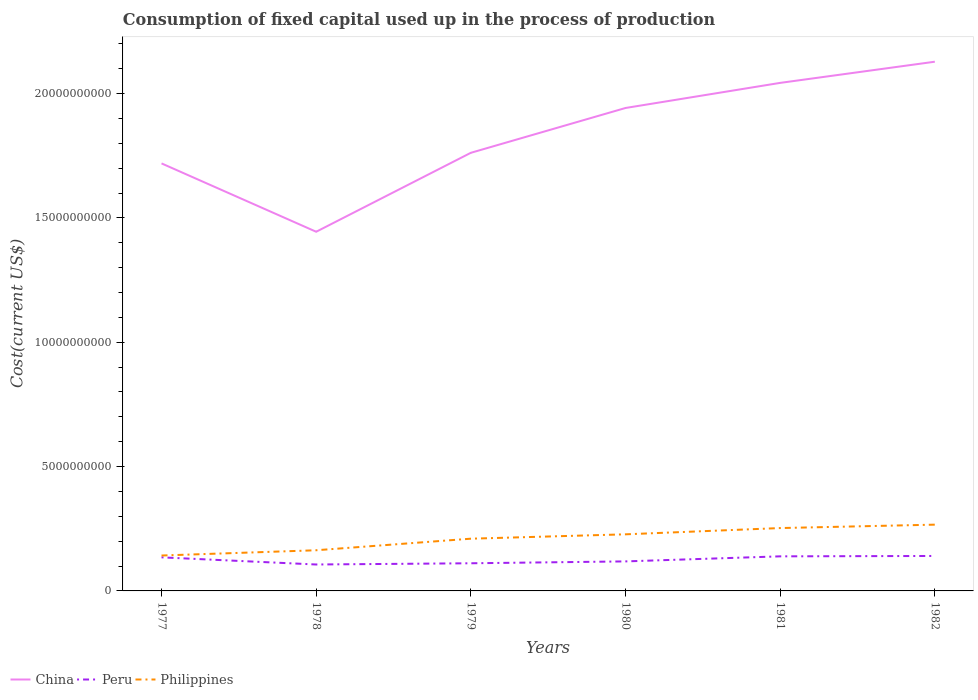How many different coloured lines are there?
Provide a short and direct response. 3. Is the number of lines equal to the number of legend labels?
Keep it short and to the point. Yes. Across all years, what is the maximum amount consumed in the process of production in Peru?
Your response must be concise. 1.06e+09. In which year was the amount consumed in the process of production in Peru maximum?
Offer a terse response. 1978. What is the total amount consumed in the process of production in Philippines in the graph?
Your answer should be very brief. -1.24e+09. What is the difference between the highest and the second highest amount consumed in the process of production in China?
Ensure brevity in your answer.  6.84e+09. Is the amount consumed in the process of production in China strictly greater than the amount consumed in the process of production in Philippines over the years?
Your response must be concise. No. How many lines are there?
Offer a very short reply. 3. How many years are there in the graph?
Offer a very short reply. 6. Does the graph contain any zero values?
Provide a succinct answer. No. How are the legend labels stacked?
Make the answer very short. Horizontal. What is the title of the graph?
Give a very brief answer. Consumption of fixed capital used up in the process of production. Does "Zimbabwe" appear as one of the legend labels in the graph?
Your answer should be very brief. No. What is the label or title of the X-axis?
Make the answer very short. Years. What is the label or title of the Y-axis?
Offer a very short reply. Cost(current US$). What is the Cost(current US$) of China in 1977?
Offer a terse response. 1.72e+1. What is the Cost(current US$) in Peru in 1977?
Make the answer very short. 1.35e+09. What is the Cost(current US$) in Philippines in 1977?
Your answer should be compact. 1.42e+09. What is the Cost(current US$) in China in 1978?
Ensure brevity in your answer.  1.44e+1. What is the Cost(current US$) in Peru in 1978?
Give a very brief answer. 1.06e+09. What is the Cost(current US$) of Philippines in 1978?
Offer a very short reply. 1.64e+09. What is the Cost(current US$) in China in 1979?
Your response must be concise. 1.76e+1. What is the Cost(current US$) in Peru in 1979?
Your response must be concise. 1.11e+09. What is the Cost(current US$) of Philippines in 1979?
Give a very brief answer. 2.10e+09. What is the Cost(current US$) of China in 1980?
Your answer should be compact. 1.94e+1. What is the Cost(current US$) of Peru in 1980?
Provide a succinct answer. 1.19e+09. What is the Cost(current US$) in Philippines in 1980?
Offer a very short reply. 2.28e+09. What is the Cost(current US$) in China in 1981?
Your answer should be very brief. 2.04e+1. What is the Cost(current US$) in Peru in 1981?
Offer a very short reply. 1.39e+09. What is the Cost(current US$) in Philippines in 1981?
Keep it short and to the point. 2.53e+09. What is the Cost(current US$) in China in 1982?
Give a very brief answer. 2.13e+1. What is the Cost(current US$) in Peru in 1982?
Give a very brief answer. 1.41e+09. What is the Cost(current US$) of Philippines in 1982?
Provide a short and direct response. 2.66e+09. Across all years, what is the maximum Cost(current US$) in China?
Your answer should be compact. 2.13e+1. Across all years, what is the maximum Cost(current US$) of Peru?
Offer a terse response. 1.41e+09. Across all years, what is the maximum Cost(current US$) of Philippines?
Give a very brief answer. 2.66e+09. Across all years, what is the minimum Cost(current US$) in China?
Make the answer very short. 1.44e+1. Across all years, what is the minimum Cost(current US$) in Peru?
Provide a short and direct response. 1.06e+09. Across all years, what is the minimum Cost(current US$) in Philippines?
Give a very brief answer. 1.42e+09. What is the total Cost(current US$) of China in the graph?
Keep it short and to the point. 1.10e+11. What is the total Cost(current US$) of Peru in the graph?
Offer a terse response. 7.51e+09. What is the total Cost(current US$) in Philippines in the graph?
Make the answer very short. 1.26e+1. What is the difference between the Cost(current US$) in China in 1977 and that in 1978?
Offer a terse response. 2.75e+09. What is the difference between the Cost(current US$) of Peru in 1977 and that in 1978?
Give a very brief answer. 2.88e+08. What is the difference between the Cost(current US$) in Philippines in 1977 and that in 1978?
Offer a very short reply. -2.12e+08. What is the difference between the Cost(current US$) in China in 1977 and that in 1979?
Your answer should be compact. -4.26e+08. What is the difference between the Cost(current US$) of Peru in 1977 and that in 1979?
Provide a succinct answer. 2.38e+08. What is the difference between the Cost(current US$) of Philippines in 1977 and that in 1979?
Offer a terse response. -6.77e+08. What is the difference between the Cost(current US$) in China in 1977 and that in 1980?
Give a very brief answer. -2.23e+09. What is the difference between the Cost(current US$) in Peru in 1977 and that in 1980?
Give a very brief answer. 1.63e+08. What is the difference between the Cost(current US$) in Philippines in 1977 and that in 1980?
Offer a very short reply. -8.52e+08. What is the difference between the Cost(current US$) of China in 1977 and that in 1981?
Keep it short and to the point. -3.24e+09. What is the difference between the Cost(current US$) in Peru in 1977 and that in 1981?
Make the answer very short. -4.03e+07. What is the difference between the Cost(current US$) in Philippines in 1977 and that in 1981?
Your answer should be very brief. -1.10e+09. What is the difference between the Cost(current US$) in China in 1977 and that in 1982?
Your answer should be very brief. -4.09e+09. What is the difference between the Cost(current US$) of Peru in 1977 and that in 1982?
Offer a very short reply. -5.58e+07. What is the difference between the Cost(current US$) in Philippines in 1977 and that in 1982?
Give a very brief answer. -1.24e+09. What is the difference between the Cost(current US$) in China in 1978 and that in 1979?
Provide a succinct answer. -3.17e+09. What is the difference between the Cost(current US$) of Peru in 1978 and that in 1979?
Make the answer very short. -4.93e+07. What is the difference between the Cost(current US$) in Philippines in 1978 and that in 1979?
Make the answer very short. -4.65e+08. What is the difference between the Cost(current US$) in China in 1978 and that in 1980?
Offer a very short reply. -4.98e+09. What is the difference between the Cost(current US$) in Peru in 1978 and that in 1980?
Make the answer very short. -1.25e+08. What is the difference between the Cost(current US$) in Philippines in 1978 and that in 1980?
Offer a very short reply. -6.41e+08. What is the difference between the Cost(current US$) in China in 1978 and that in 1981?
Provide a succinct answer. -5.99e+09. What is the difference between the Cost(current US$) of Peru in 1978 and that in 1981?
Your answer should be compact. -3.28e+08. What is the difference between the Cost(current US$) in Philippines in 1978 and that in 1981?
Keep it short and to the point. -8.92e+08. What is the difference between the Cost(current US$) in China in 1978 and that in 1982?
Give a very brief answer. -6.84e+09. What is the difference between the Cost(current US$) in Peru in 1978 and that in 1982?
Make the answer very short. -3.43e+08. What is the difference between the Cost(current US$) of Philippines in 1978 and that in 1982?
Your response must be concise. -1.03e+09. What is the difference between the Cost(current US$) in China in 1979 and that in 1980?
Make the answer very short. -1.80e+09. What is the difference between the Cost(current US$) of Peru in 1979 and that in 1980?
Provide a short and direct response. -7.55e+07. What is the difference between the Cost(current US$) in Philippines in 1979 and that in 1980?
Offer a very short reply. -1.76e+08. What is the difference between the Cost(current US$) in China in 1979 and that in 1981?
Give a very brief answer. -2.81e+09. What is the difference between the Cost(current US$) in Peru in 1979 and that in 1981?
Keep it short and to the point. -2.78e+08. What is the difference between the Cost(current US$) in Philippines in 1979 and that in 1981?
Provide a short and direct response. -4.27e+08. What is the difference between the Cost(current US$) of China in 1979 and that in 1982?
Your response must be concise. -3.66e+09. What is the difference between the Cost(current US$) of Peru in 1979 and that in 1982?
Make the answer very short. -2.94e+08. What is the difference between the Cost(current US$) of Philippines in 1979 and that in 1982?
Your response must be concise. -5.64e+08. What is the difference between the Cost(current US$) in China in 1980 and that in 1981?
Keep it short and to the point. -1.01e+09. What is the difference between the Cost(current US$) in Peru in 1980 and that in 1981?
Make the answer very short. -2.03e+08. What is the difference between the Cost(current US$) of Philippines in 1980 and that in 1981?
Offer a very short reply. -2.52e+08. What is the difference between the Cost(current US$) in China in 1980 and that in 1982?
Your answer should be compact. -1.86e+09. What is the difference between the Cost(current US$) of Peru in 1980 and that in 1982?
Make the answer very short. -2.19e+08. What is the difference between the Cost(current US$) of Philippines in 1980 and that in 1982?
Your answer should be compact. -3.89e+08. What is the difference between the Cost(current US$) of China in 1981 and that in 1982?
Your answer should be very brief. -8.51e+08. What is the difference between the Cost(current US$) of Peru in 1981 and that in 1982?
Ensure brevity in your answer.  -1.55e+07. What is the difference between the Cost(current US$) of Philippines in 1981 and that in 1982?
Make the answer very short. -1.37e+08. What is the difference between the Cost(current US$) of China in 1977 and the Cost(current US$) of Peru in 1978?
Your answer should be very brief. 1.61e+1. What is the difference between the Cost(current US$) in China in 1977 and the Cost(current US$) in Philippines in 1978?
Make the answer very short. 1.56e+1. What is the difference between the Cost(current US$) of Peru in 1977 and the Cost(current US$) of Philippines in 1978?
Make the answer very short. -2.85e+08. What is the difference between the Cost(current US$) in China in 1977 and the Cost(current US$) in Peru in 1979?
Your answer should be compact. 1.61e+1. What is the difference between the Cost(current US$) of China in 1977 and the Cost(current US$) of Philippines in 1979?
Your response must be concise. 1.51e+1. What is the difference between the Cost(current US$) of Peru in 1977 and the Cost(current US$) of Philippines in 1979?
Your response must be concise. -7.50e+08. What is the difference between the Cost(current US$) in China in 1977 and the Cost(current US$) in Peru in 1980?
Offer a terse response. 1.60e+1. What is the difference between the Cost(current US$) of China in 1977 and the Cost(current US$) of Philippines in 1980?
Provide a short and direct response. 1.49e+1. What is the difference between the Cost(current US$) of Peru in 1977 and the Cost(current US$) of Philippines in 1980?
Your answer should be very brief. -9.26e+08. What is the difference between the Cost(current US$) in China in 1977 and the Cost(current US$) in Peru in 1981?
Ensure brevity in your answer.  1.58e+1. What is the difference between the Cost(current US$) of China in 1977 and the Cost(current US$) of Philippines in 1981?
Your answer should be very brief. 1.47e+1. What is the difference between the Cost(current US$) of Peru in 1977 and the Cost(current US$) of Philippines in 1981?
Your answer should be compact. -1.18e+09. What is the difference between the Cost(current US$) in China in 1977 and the Cost(current US$) in Peru in 1982?
Ensure brevity in your answer.  1.58e+1. What is the difference between the Cost(current US$) of China in 1977 and the Cost(current US$) of Philippines in 1982?
Keep it short and to the point. 1.45e+1. What is the difference between the Cost(current US$) of Peru in 1977 and the Cost(current US$) of Philippines in 1982?
Give a very brief answer. -1.31e+09. What is the difference between the Cost(current US$) in China in 1978 and the Cost(current US$) in Peru in 1979?
Your answer should be very brief. 1.33e+1. What is the difference between the Cost(current US$) of China in 1978 and the Cost(current US$) of Philippines in 1979?
Provide a short and direct response. 1.23e+1. What is the difference between the Cost(current US$) in Peru in 1978 and the Cost(current US$) in Philippines in 1979?
Your response must be concise. -1.04e+09. What is the difference between the Cost(current US$) of China in 1978 and the Cost(current US$) of Peru in 1980?
Your response must be concise. 1.33e+1. What is the difference between the Cost(current US$) in China in 1978 and the Cost(current US$) in Philippines in 1980?
Keep it short and to the point. 1.22e+1. What is the difference between the Cost(current US$) in Peru in 1978 and the Cost(current US$) in Philippines in 1980?
Ensure brevity in your answer.  -1.21e+09. What is the difference between the Cost(current US$) in China in 1978 and the Cost(current US$) in Peru in 1981?
Your answer should be compact. 1.31e+1. What is the difference between the Cost(current US$) in China in 1978 and the Cost(current US$) in Philippines in 1981?
Offer a terse response. 1.19e+1. What is the difference between the Cost(current US$) in Peru in 1978 and the Cost(current US$) in Philippines in 1981?
Offer a very short reply. -1.47e+09. What is the difference between the Cost(current US$) in China in 1978 and the Cost(current US$) in Peru in 1982?
Your answer should be compact. 1.30e+1. What is the difference between the Cost(current US$) in China in 1978 and the Cost(current US$) in Philippines in 1982?
Keep it short and to the point. 1.18e+1. What is the difference between the Cost(current US$) of Peru in 1978 and the Cost(current US$) of Philippines in 1982?
Offer a very short reply. -1.60e+09. What is the difference between the Cost(current US$) of China in 1979 and the Cost(current US$) of Peru in 1980?
Your response must be concise. 1.64e+1. What is the difference between the Cost(current US$) in China in 1979 and the Cost(current US$) in Philippines in 1980?
Give a very brief answer. 1.53e+1. What is the difference between the Cost(current US$) of Peru in 1979 and the Cost(current US$) of Philippines in 1980?
Your response must be concise. -1.16e+09. What is the difference between the Cost(current US$) of China in 1979 and the Cost(current US$) of Peru in 1981?
Provide a short and direct response. 1.62e+1. What is the difference between the Cost(current US$) in China in 1979 and the Cost(current US$) in Philippines in 1981?
Offer a very short reply. 1.51e+1. What is the difference between the Cost(current US$) in Peru in 1979 and the Cost(current US$) in Philippines in 1981?
Offer a very short reply. -1.42e+09. What is the difference between the Cost(current US$) of China in 1979 and the Cost(current US$) of Peru in 1982?
Keep it short and to the point. 1.62e+1. What is the difference between the Cost(current US$) of China in 1979 and the Cost(current US$) of Philippines in 1982?
Your answer should be very brief. 1.50e+1. What is the difference between the Cost(current US$) of Peru in 1979 and the Cost(current US$) of Philippines in 1982?
Your answer should be very brief. -1.55e+09. What is the difference between the Cost(current US$) of China in 1980 and the Cost(current US$) of Peru in 1981?
Ensure brevity in your answer.  1.80e+1. What is the difference between the Cost(current US$) of China in 1980 and the Cost(current US$) of Philippines in 1981?
Provide a succinct answer. 1.69e+1. What is the difference between the Cost(current US$) of Peru in 1980 and the Cost(current US$) of Philippines in 1981?
Your answer should be very brief. -1.34e+09. What is the difference between the Cost(current US$) of China in 1980 and the Cost(current US$) of Peru in 1982?
Make the answer very short. 1.80e+1. What is the difference between the Cost(current US$) in China in 1980 and the Cost(current US$) in Philippines in 1982?
Your answer should be very brief. 1.68e+1. What is the difference between the Cost(current US$) in Peru in 1980 and the Cost(current US$) in Philippines in 1982?
Offer a terse response. -1.48e+09. What is the difference between the Cost(current US$) of China in 1981 and the Cost(current US$) of Peru in 1982?
Your answer should be very brief. 1.90e+1. What is the difference between the Cost(current US$) of China in 1981 and the Cost(current US$) of Philippines in 1982?
Give a very brief answer. 1.78e+1. What is the difference between the Cost(current US$) of Peru in 1981 and the Cost(current US$) of Philippines in 1982?
Ensure brevity in your answer.  -1.27e+09. What is the average Cost(current US$) of China per year?
Offer a very short reply. 1.84e+1. What is the average Cost(current US$) of Peru per year?
Ensure brevity in your answer.  1.25e+09. What is the average Cost(current US$) in Philippines per year?
Provide a short and direct response. 2.10e+09. In the year 1977, what is the difference between the Cost(current US$) in China and Cost(current US$) in Peru?
Offer a terse response. 1.58e+1. In the year 1977, what is the difference between the Cost(current US$) of China and Cost(current US$) of Philippines?
Provide a short and direct response. 1.58e+1. In the year 1977, what is the difference between the Cost(current US$) in Peru and Cost(current US$) in Philippines?
Offer a very short reply. -7.37e+07. In the year 1978, what is the difference between the Cost(current US$) in China and Cost(current US$) in Peru?
Ensure brevity in your answer.  1.34e+1. In the year 1978, what is the difference between the Cost(current US$) in China and Cost(current US$) in Philippines?
Offer a terse response. 1.28e+1. In the year 1978, what is the difference between the Cost(current US$) of Peru and Cost(current US$) of Philippines?
Your response must be concise. -5.73e+08. In the year 1979, what is the difference between the Cost(current US$) in China and Cost(current US$) in Peru?
Give a very brief answer. 1.65e+1. In the year 1979, what is the difference between the Cost(current US$) of China and Cost(current US$) of Philippines?
Offer a terse response. 1.55e+1. In the year 1979, what is the difference between the Cost(current US$) in Peru and Cost(current US$) in Philippines?
Offer a very short reply. -9.89e+08. In the year 1980, what is the difference between the Cost(current US$) of China and Cost(current US$) of Peru?
Give a very brief answer. 1.82e+1. In the year 1980, what is the difference between the Cost(current US$) of China and Cost(current US$) of Philippines?
Your answer should be very brief. 1.71e+1. In the year 1980, what is the difference between the Cost(current US$) of Peru and Cost(current US$) of Philippines?
Keep it short and to the point. -1.09e+09. In the year 1981, what is the difference between the Cost(current US$) of China and Cost(current US$) of Peru?
Offer a very short reply. 1.90e+1. In the year 1981, what is the difference between the Cost(current US$) in China and Cost(current US$) in Philippines?
Your answer should be very brief. 1.79e+1. In the year 1981, what is the difference between the Cost(current US$) of Peru and Cost(current US$) of Philippines?
Ensure brevity in your answer.  -1.14e+09. In the year 1982, what is the difference between the Cost(current US$) in China and Cost(current US$) in Peru?
Keep it short and to the point. 1.99e+1. In the year 1982, what is the difference between the Cost(current US$) of China and Cost(current US$) of Philippines?
Offer a terse response. 1.86e+1. In the year 1982, what is the difference between the Cost(current US$) of Peru and Cost(current US$) of Philippines?
Your answer should be compact. -1.26e+09. What is the ratio of the Cost(current US$) in China in 1977 to that in 1978?
Offer a very short reply. 1.19. What is the ratio of the Cost(current US$) in Peru in 1977 to that in 1978?
Make the answer very short. 1.27. What is the ratio of the Cost(current US$) in Philippines in 1977 to that in 1978?
Offer a terse response. 0.87. What is the ratio of the Cost(current US$) in China in 1977 to that in 1979?
Offer a terse response. 0.98. What is the ratio of the Cost(current US$) in Peru in 1977 to that in 1979?
Provide a succinct answer. 1.21. What is the ratio of the Cost(current US$) in Philippines in 1977 to that in 1979?
Ensure brevity in your answer.  0.68. What is the ratio of the Cost(current US$) in China in 1977 to that in 1980?
Give a very brief answer. 0.89. What is the ratio of the Cost(current US$) in Peru in 1977 to that in 1980?
Your answer should be very brief. 1.14. What is the ratio of the Cost(current US$) of Philippines in 1977 to that in 1980?
Your answer should be very brief. 0.63. What is the ratio of the Cost(current US$) of China in 1977 to that in 1981?
Provide a short and direct response. 0.84. What is the ratio of the Cost(current US$) of Peru in 1977 to that in 1981?
Provide a short and direct response. 0.97. What is the ratio of the Cost(current US$) of Philippines in 1977 to that in 1981?
Make the answer very short. 0.56. What is the ratio of the Cost(current US$) in China in 1977 to that in 1982?
Offer a very short reply. 0.81. What is the ratio of the Cost(current US$) of Peru in 1977 to that in 1982?
Make the answer very short. 0.96. What is the ratio of the Cost(current US$) in Philippines in 1977 to that in 1982?
Keep it short and to the point. 0.53. What is the ratio of the Cost(current US$) of China in 1978 to that in 1979?
Offer a very short reply. 0.82. What is the ratio of the Cost(current US$) in Peru in 1978 to that in 1979?
Provide a short and direct response. 0.96. What is the ratio of the Cost(current US$) in Philippines in 1978 to that in 1979?
Your answer should be very brief. 0.78. What is the ratio of the Cost(current US$) in China in 1978 to that in 1980?
Offer a very short reply. 0.74. What is the ratio of the Cost(current US$) of Peru in 1978 to that in 1980?
Ensure brevity in your answer.  0.89. What is the ratio of the Cost(current US$) of Philippines in 1978 to that in 1980?
Give a very brief answer. 0.72. What is the ratio of the Cost(current US$) in China in 1978 to that in 1981?
Give a very brief answer. 0.71. What is the ratio of the Cost(current US$) of Peru in 1978 to that in 1981?
Your answer should be compact. 0.76. What is the ratio of the Cost(current US$) of Philippines in 1978 to that in 1981?
Your answer should be very brief. 0.65. What is the ratio of the Cost(current US$) of China in 1978 to that in 1982?
Your answer should be very brief. 0.68. What is the ratio of the Cost(current US$) of Peru in 1978 to that in 1982?
Your response must be concise. 0.76. What is the ratio of the Cost(current US$) of Philippines in 1978 to that in 1982?
Offer a very short reply. 0.61. What is the ratio of the Cost(current US$) of China in 1979 to that in 1980?
Keep it short and to the point. 0.91. What is the ratio of the Cost(current US$) in Peru in 1979 to that in 1980?
Provide a succinct answer. 0.94. What is the ratio of the Cost(current US$) in Philippines in 1979 to that in 1980?
Offer a terse response. 0.92. What is the ratio of the Cost(current US$) of China in 1979 to that in 1981?
Keep it short and to the point. 0.86. What is the ratio of the Cost(current US$) in Peru in 1979 to that in 1981?
Keep it short and to the point. 0.8. What is the ratio of the Cost(current US$) in Philippines in 1979 to that in 1981?
Provide a short and direct response. 0.83. What is the ratio of the Cost(current US$) of China in 1979 to that in 1982?
Provide a succinct answer. 0.83. What is the ratio of the Cost(current US$) in Peru in 1979 to that in 1982?
Ensure brevity in your answer.  0.79. What is the ratio of the Cost(current US$) of Philippines in 1979 to that in 1982?
Offer a terse response. 0.79. What is the ratio of the Cost(current US$) of China in 1980 to that in 1981?
Offer a terse response. 0.95. What is the ratio of the Cost(current US$) of Peru in 1980 to that in 1981?
Your answer should be very brief. 0.85. What is the ratio of the Cost(current US$) of Philippines in 1980 to that in 1981?
Your response must be concise. 0.9. What is the ratio of the Cost(current US$) in China in 1980 to that in 1982?
Ensure brevity in your answer.  0.91. What is the ratio of the Cost(current US$) in Peru in 1980 to that in 1982?
Your answer should be very brief. 0.84. What is the ratio of the Cost(current US$) of Philippines in 1980 to that in 1982?
Your answer should be very brief. 0.85. What is the ratio of the Cost(current US$) in China in 1981 to that in 1982?
Your response must be concise. 0.96. What is the ratio of the Cost(current US$) of Peru in 1981 to that in 1982?
Offer a terse response. 0.99. What is the ratio of the Cost(current US$) of Philippines in 1981 to that in 1982?
Your response must be concise. 0.95. What is the difference between the highest and the second highest Cost(current US$) in China?
Offer a terse response. 8.51e+08. What is the difference between the highest and the second highest Cost(current US$) of Peru?
Provide a short and direct response. 1.55e+07. What is the difference between the highest and the second highest Cost(current US$) in Philippines?
Your answer should be very brief. 1.37e+08. What is the difference between the highest and the lowest Cost(current US$) in China?
Make the answer very short. 6.84e+09. What is the difference between the highest and the lowest Cost(current US$) of Peru?
Provide a succinct answer. 3.43e+08. What is the difference between the highest and the lowest Cost(current US$) in Philippines?
Offer a terse response. 1.24e+09. 